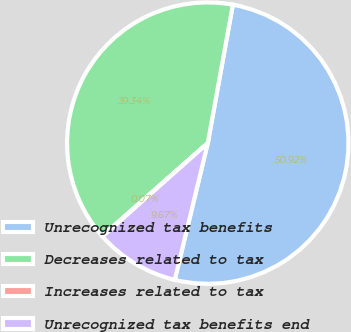<chart> <loc_0><loc_0><loc_500><loc_500><pie_chart><fcel>Unrecognized tax benefits<fcel>Decreases related to tax<fcel>Increases related to tax<fcel>Unrecognized tax benefits end<nl><fcel>50.92%<fcel>39.34%<fcel>0.07%<fcel>9.67%<nl></chart> 